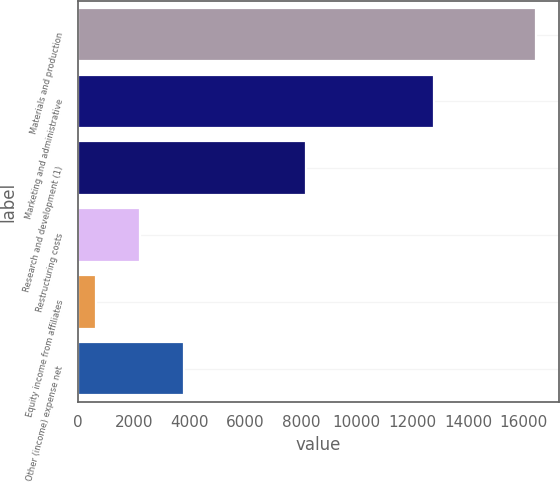Convert chart to OTSL. <chart><loc_0><loc_0><loc_500><loc_500><bar_chart><fcel>Materials and production<fcel>Marketing and administrative<fcel>Research and development (1)<fcel>Restructuring costs<fcel>Equity income from affiliates<fcel>Other (income) expense net<nl><fcel>16446<fcel>12776<fcel>8168<fcel>2222.4<fcel>642<fcel>3802.8<nl></chart> 